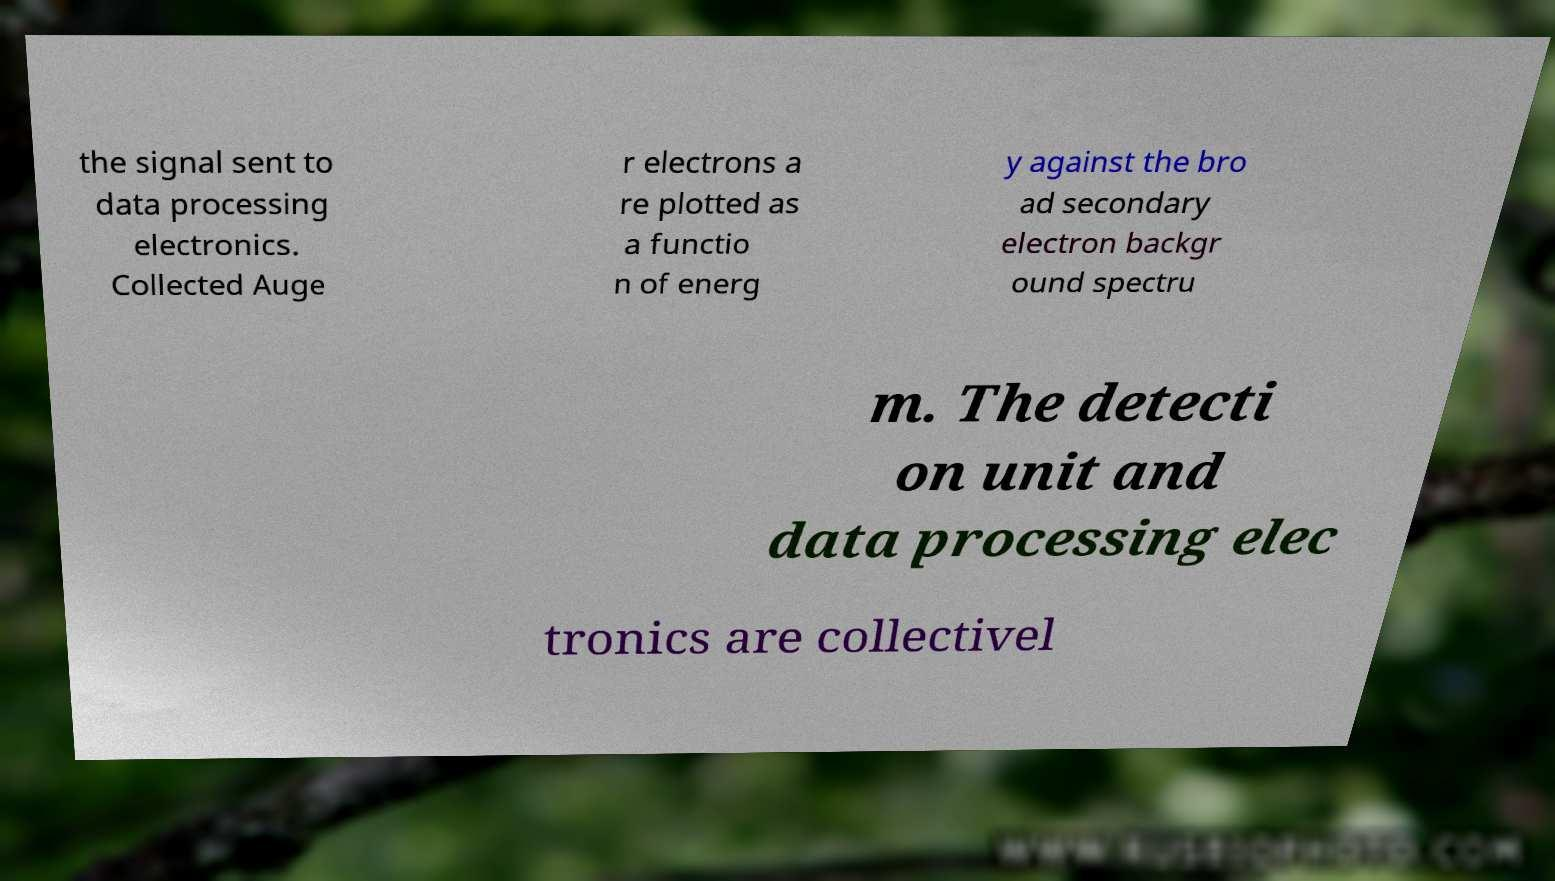What messages or text are displayed in this image? I need them in a readable, typed format. the signal sent to data processing electronics. Collected Auge r electrons a re plotted as a functio n of energ y against the bro ad secondary electron backgr ound spectru m. The detecti on unit and data processing elec tronics are collectivel 